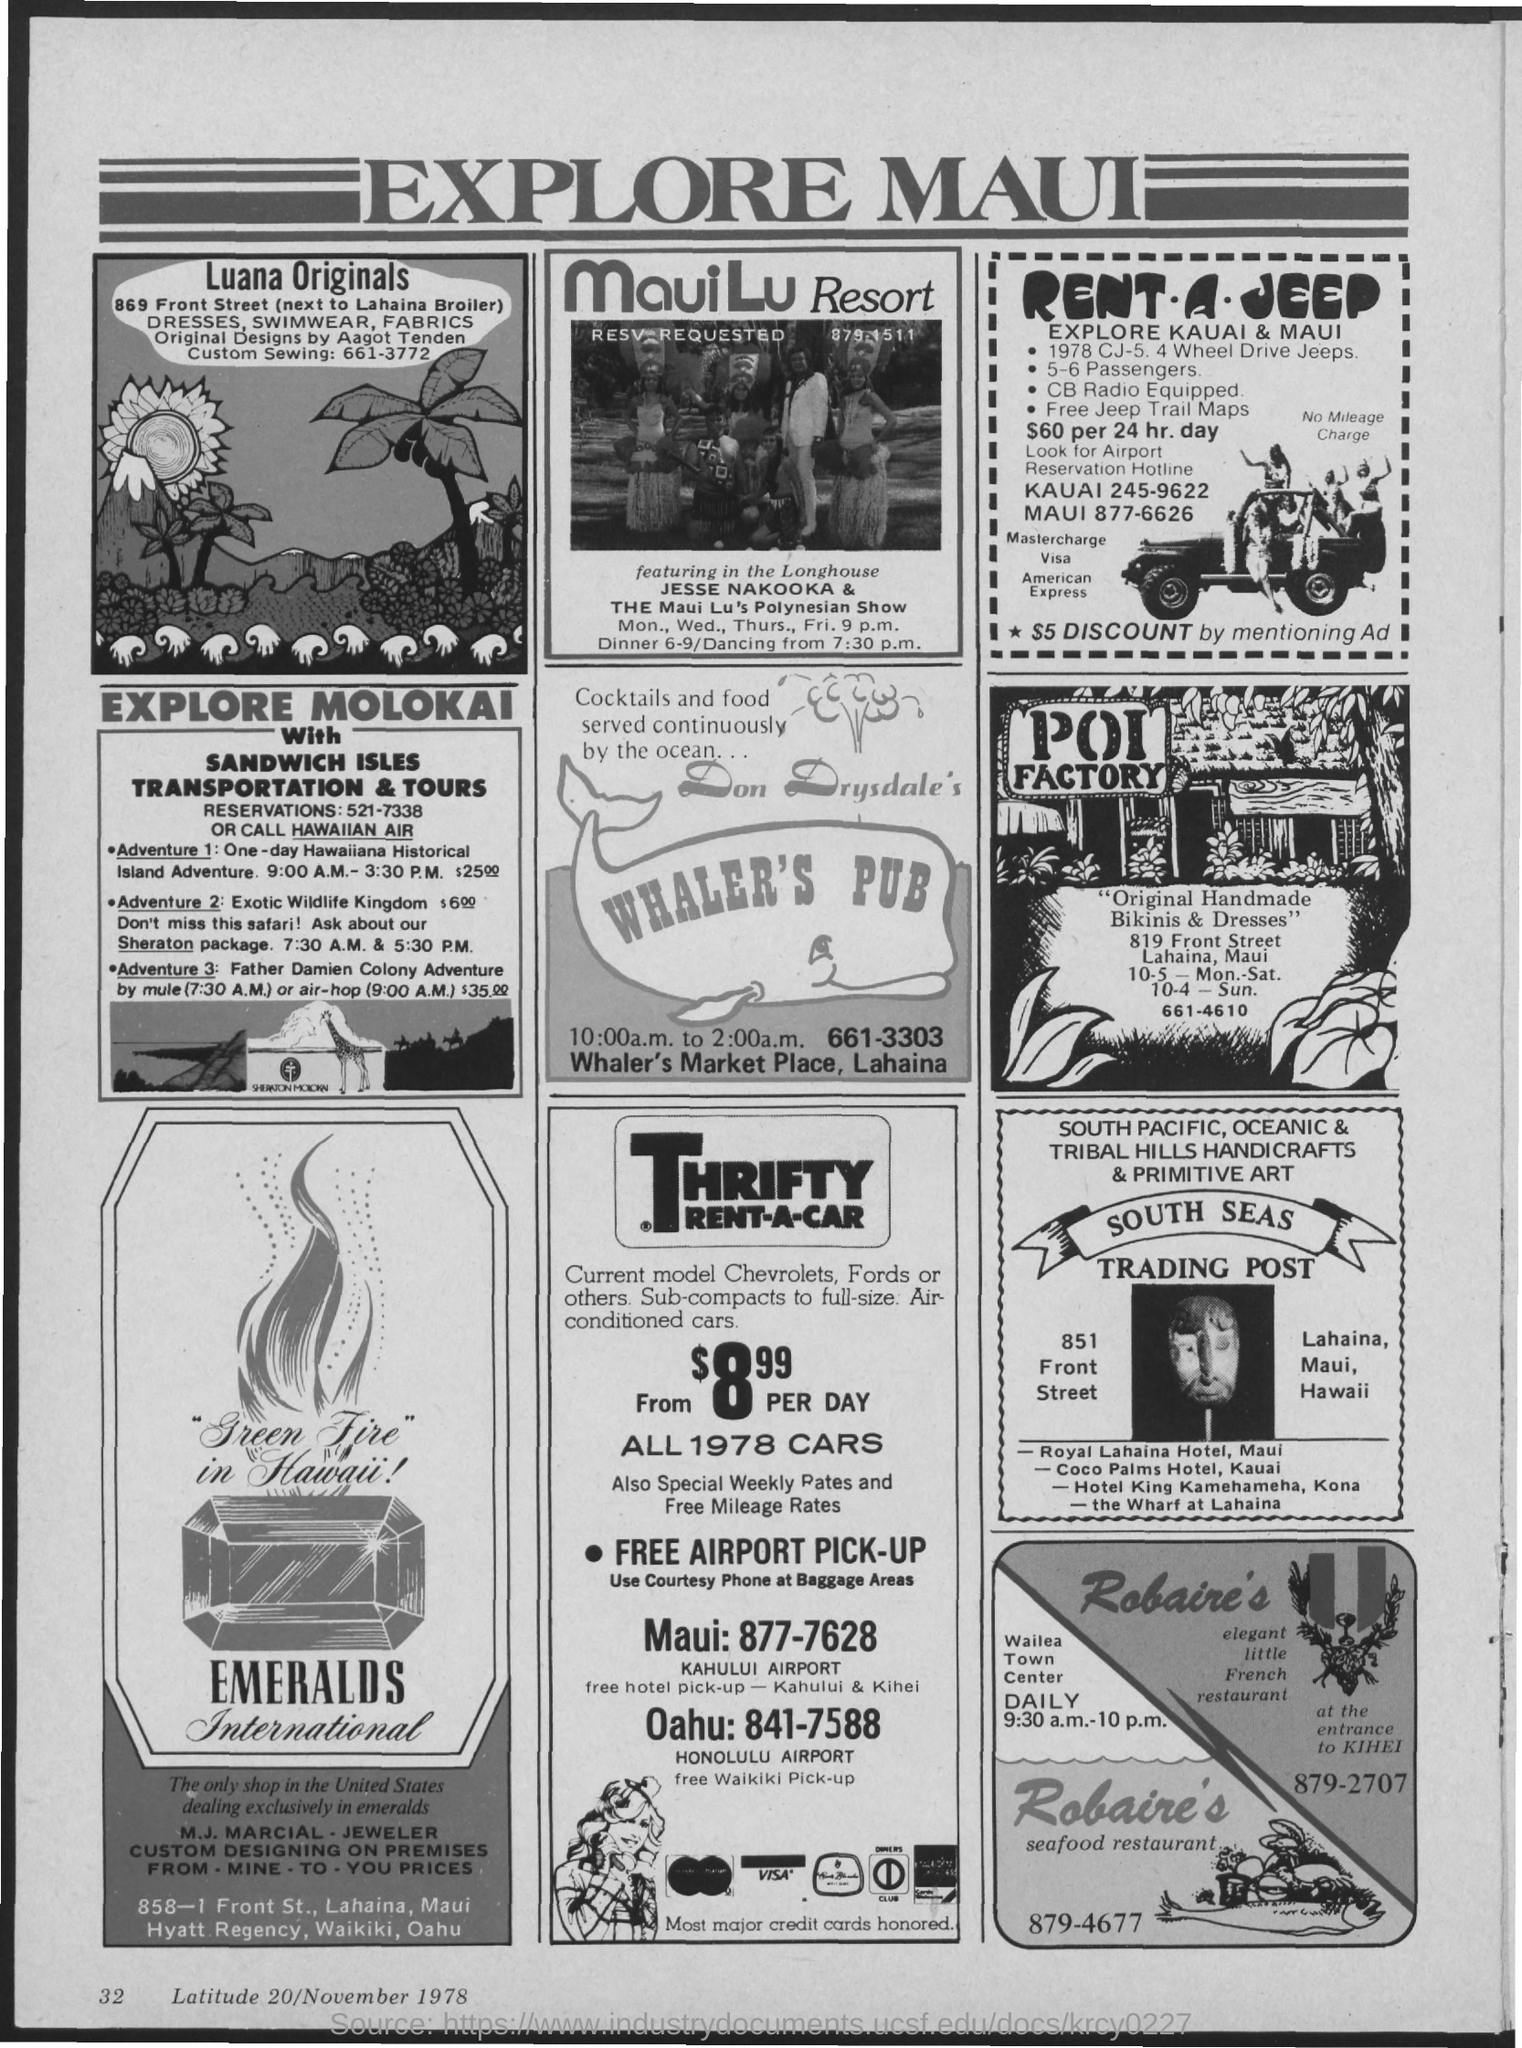What is the heading of advertisement?
Give a very brief answer. Explore maui. What is the address of whaler's pub?
Make the answer very short. Whaler's market place, lahaina. 